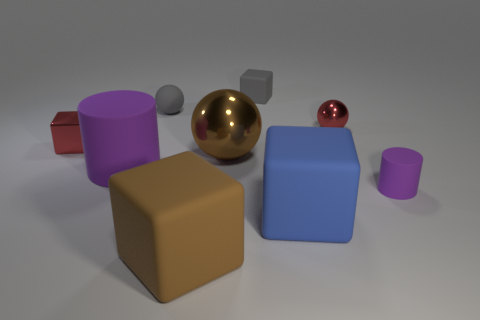Subtract 1 balls. How many balls are left? 2 Subtract all yellow blocks. Subtract all purple cylinders. How many blocks are left? 4 Subtract all blocks. How many objects are left? 5 Add 1 big gray objects. How many objects exist? 10 Add 4 big purple rubber cylinders. How many big purple rubber cylinders are left? 5 Add 2 large brown matte cubes. How many large brown matte cubes exist? 3 Subtract 1 blue blocks. How many objects are left? 8 Subtract all tiny cylinders. Subtract all red matte balls. How many objects are left? 8 